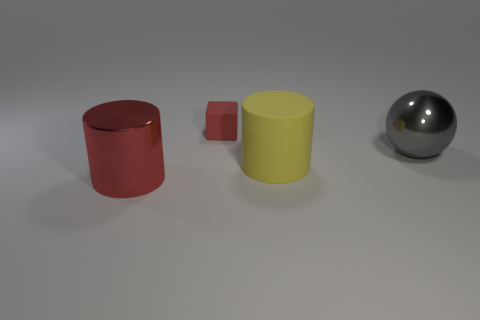Add 3 large blue matte spheres. How many objects exist? 7 Subtract all spheres. How many objects are left? 3 Subtract all large shiny objects. Subtract all blocks. How many objects are left? 1 Add 2 rubber cylinders. How many rubber cylinders are left? 3 Add 2 yellow matte objects. How many yellow matte objects exist? 3 Subtract 0 green blocks. How many objects are left? 4 